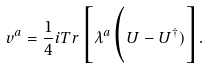<formula> <loc_0><loc_0><loc_500><loc_500>v ^ { a } = \frac { 1 } { 4 } i T r \Big [ \lambda ^ { a } \Big ( U - U ^ { \dagger } ) \Big ] .</formula> 